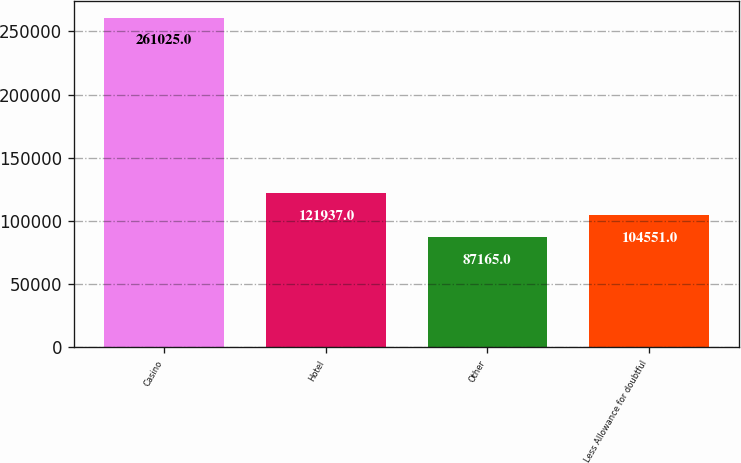<chart> <loc_0><loc_0><loc_500><loc_500><bar_chart><fcel>Casino<fcel>Hotel<fcel>Other<fcel>Less Allowance for doubtful<nl><fcel>261025<fcel>121937<fcel>87165<fcel>104551<nl></chart> 